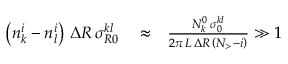<formula> <loc_0><loc_0><loc_500><loc_500>\begin{array} { r l r } { \left ( n _ { k } ^ { i } - n _ { l } ^ { i } \right ) \, \Delta R \, \sigma _ { R 0 } ^ { k l } } & \approx } & { \frac { N _ { k } ^ { 0 } \, \sigma _ { 0 } ^ { k l } } { 2 \pi \, L \, \Delta R \, \left ( N _ { > } - i \right ) } \gg 1 } \end{array}</formula> 